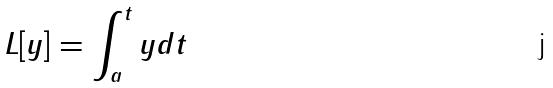<formula> <loc_0><loc_0><loc_500><loc_500>L [ y ] = \int _ { a } ^ { t } y d t</formula> 